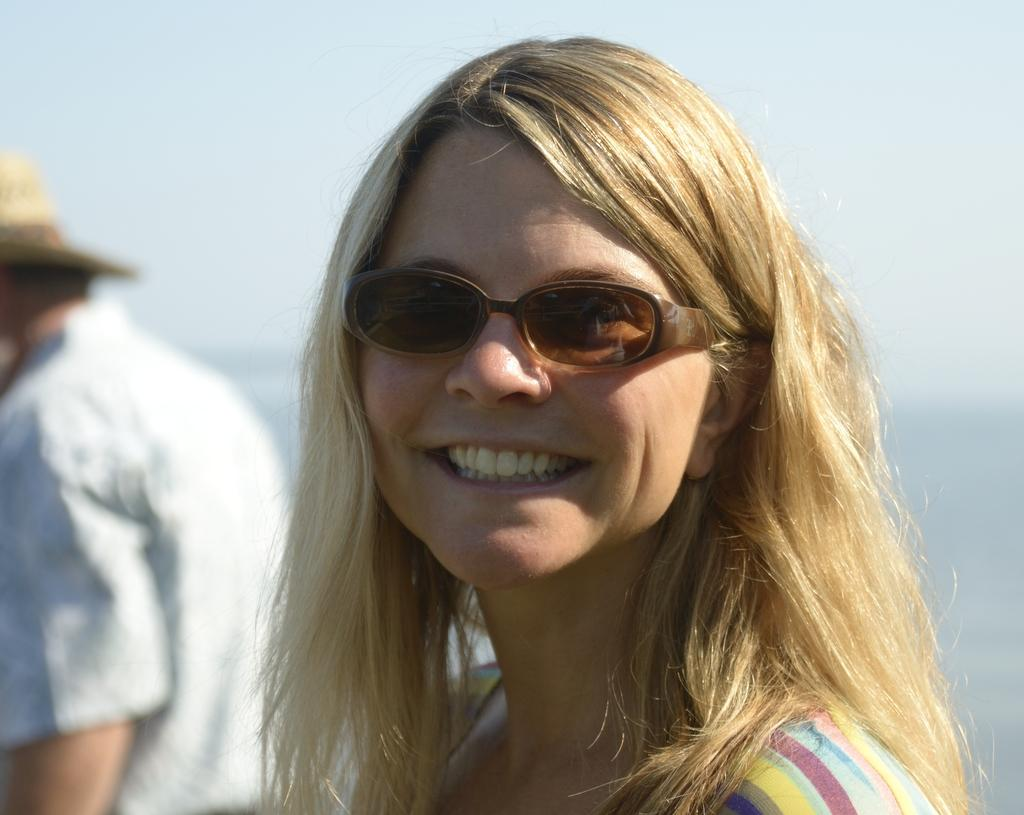Who can be seen in the image? There are people in the image. Can you describe one of the individuals in the image? A woman is present in the image. What is the woman doing in the image? The woman is smiling. What accessory is the woman wearing in the image? The woman is wearing spectacles. What type of account does the woman have in the image? There is no information about any accounts in the image; it only shows a woman smiling and wearing spectacles. 